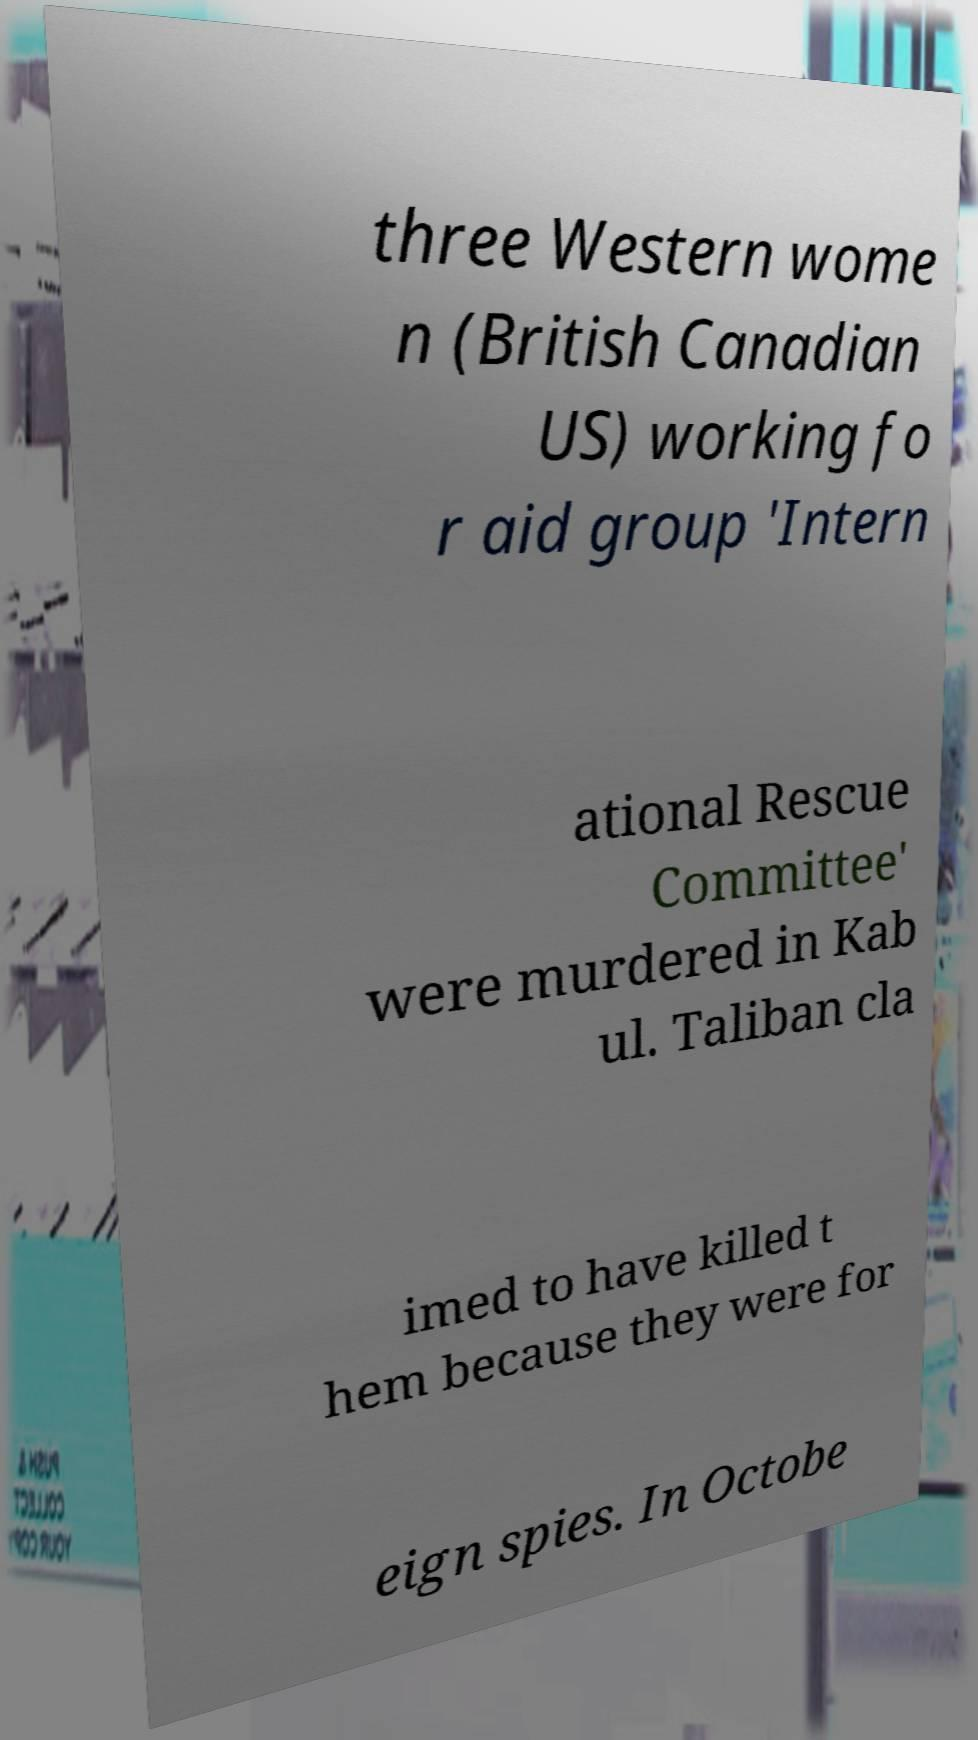I need the written content from this picture converted into text. Can you do that? three Western wome n (British Canadian US) working fo r aid group 'Intern ational Rescue Committee' were murdered in Kab ul. Taliban cla imed to have killed t hem because they were for eign spies. In Octobe 